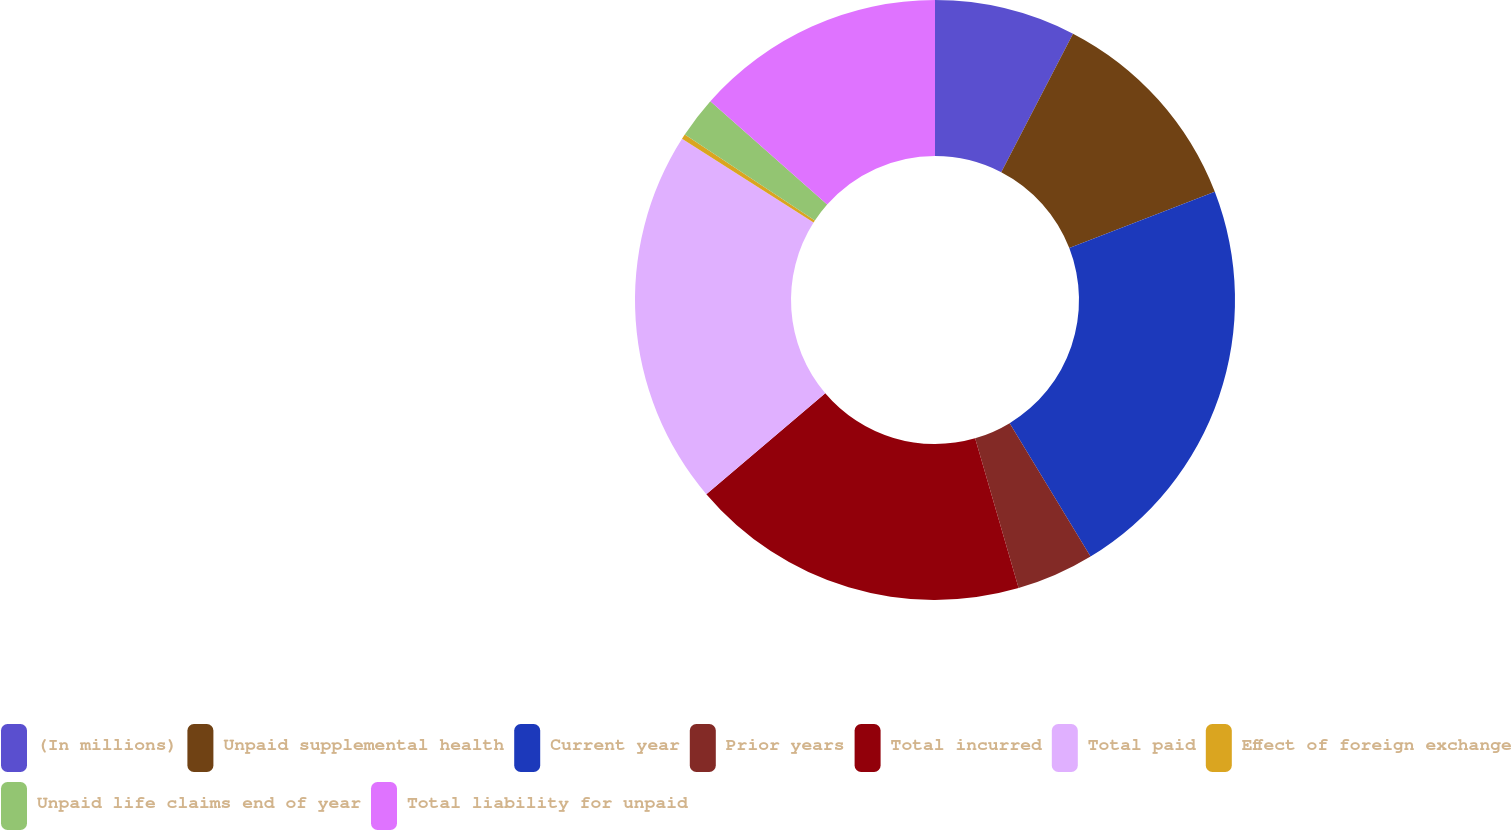Convert chart. <chart><loc_0><loc_0><loc_500><loc_500><pie_chart><fcel>(In millions)<fcel>Unpaid supplemental health<fcel>Current year<fcel>Prior years<fcel>Total incurred<fcel>Total paid<fcel>Effect of foreign exchange<fcel>Unpaid life claims end of year<fcel>Total liability for unpaid<nl><fcel>7.61%<fcel>11.52%<fcel>22.2%<fcel>4.18%<fcel>18.29%<fcel>20.24%<fcel>0.27%<fcel>2.23%<fcel>13.47%<nl></chart> 